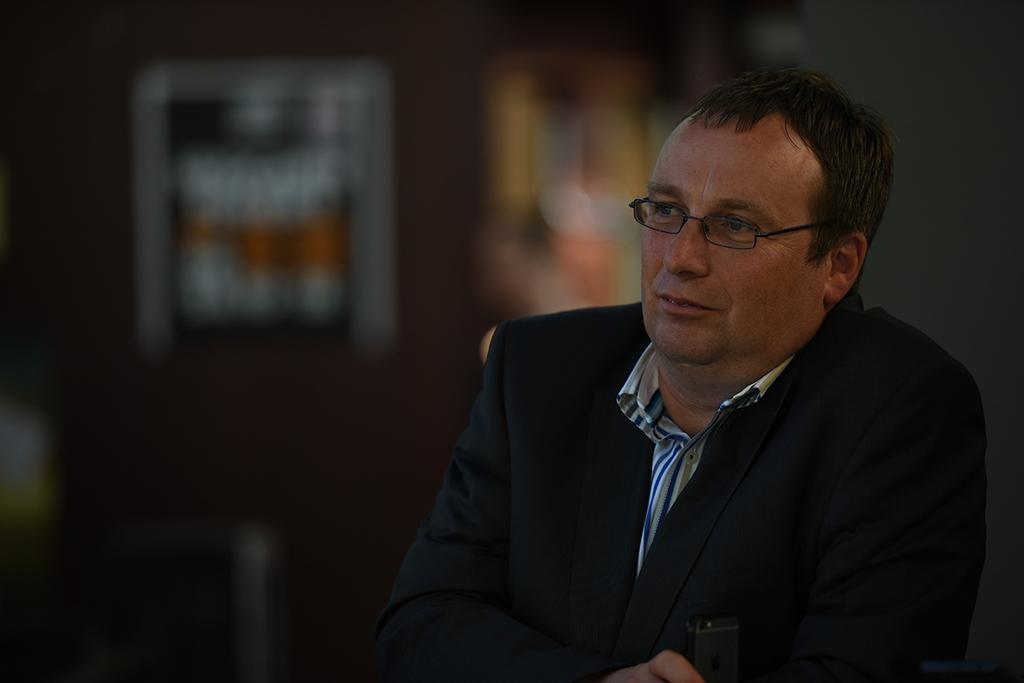Who is present in the image? There is a man in the image. What is the man wearing? The man is wearing a blazer and spectacles. Can you describe the background of the image? The background of the image is blurry. What type of bear can be seen holding a lock in the image? There is no bear or lock present in the image. What color is the chalk used to draw on the man's blazer in the image? There is no chalk or drawing on the man's blazer in the image. 